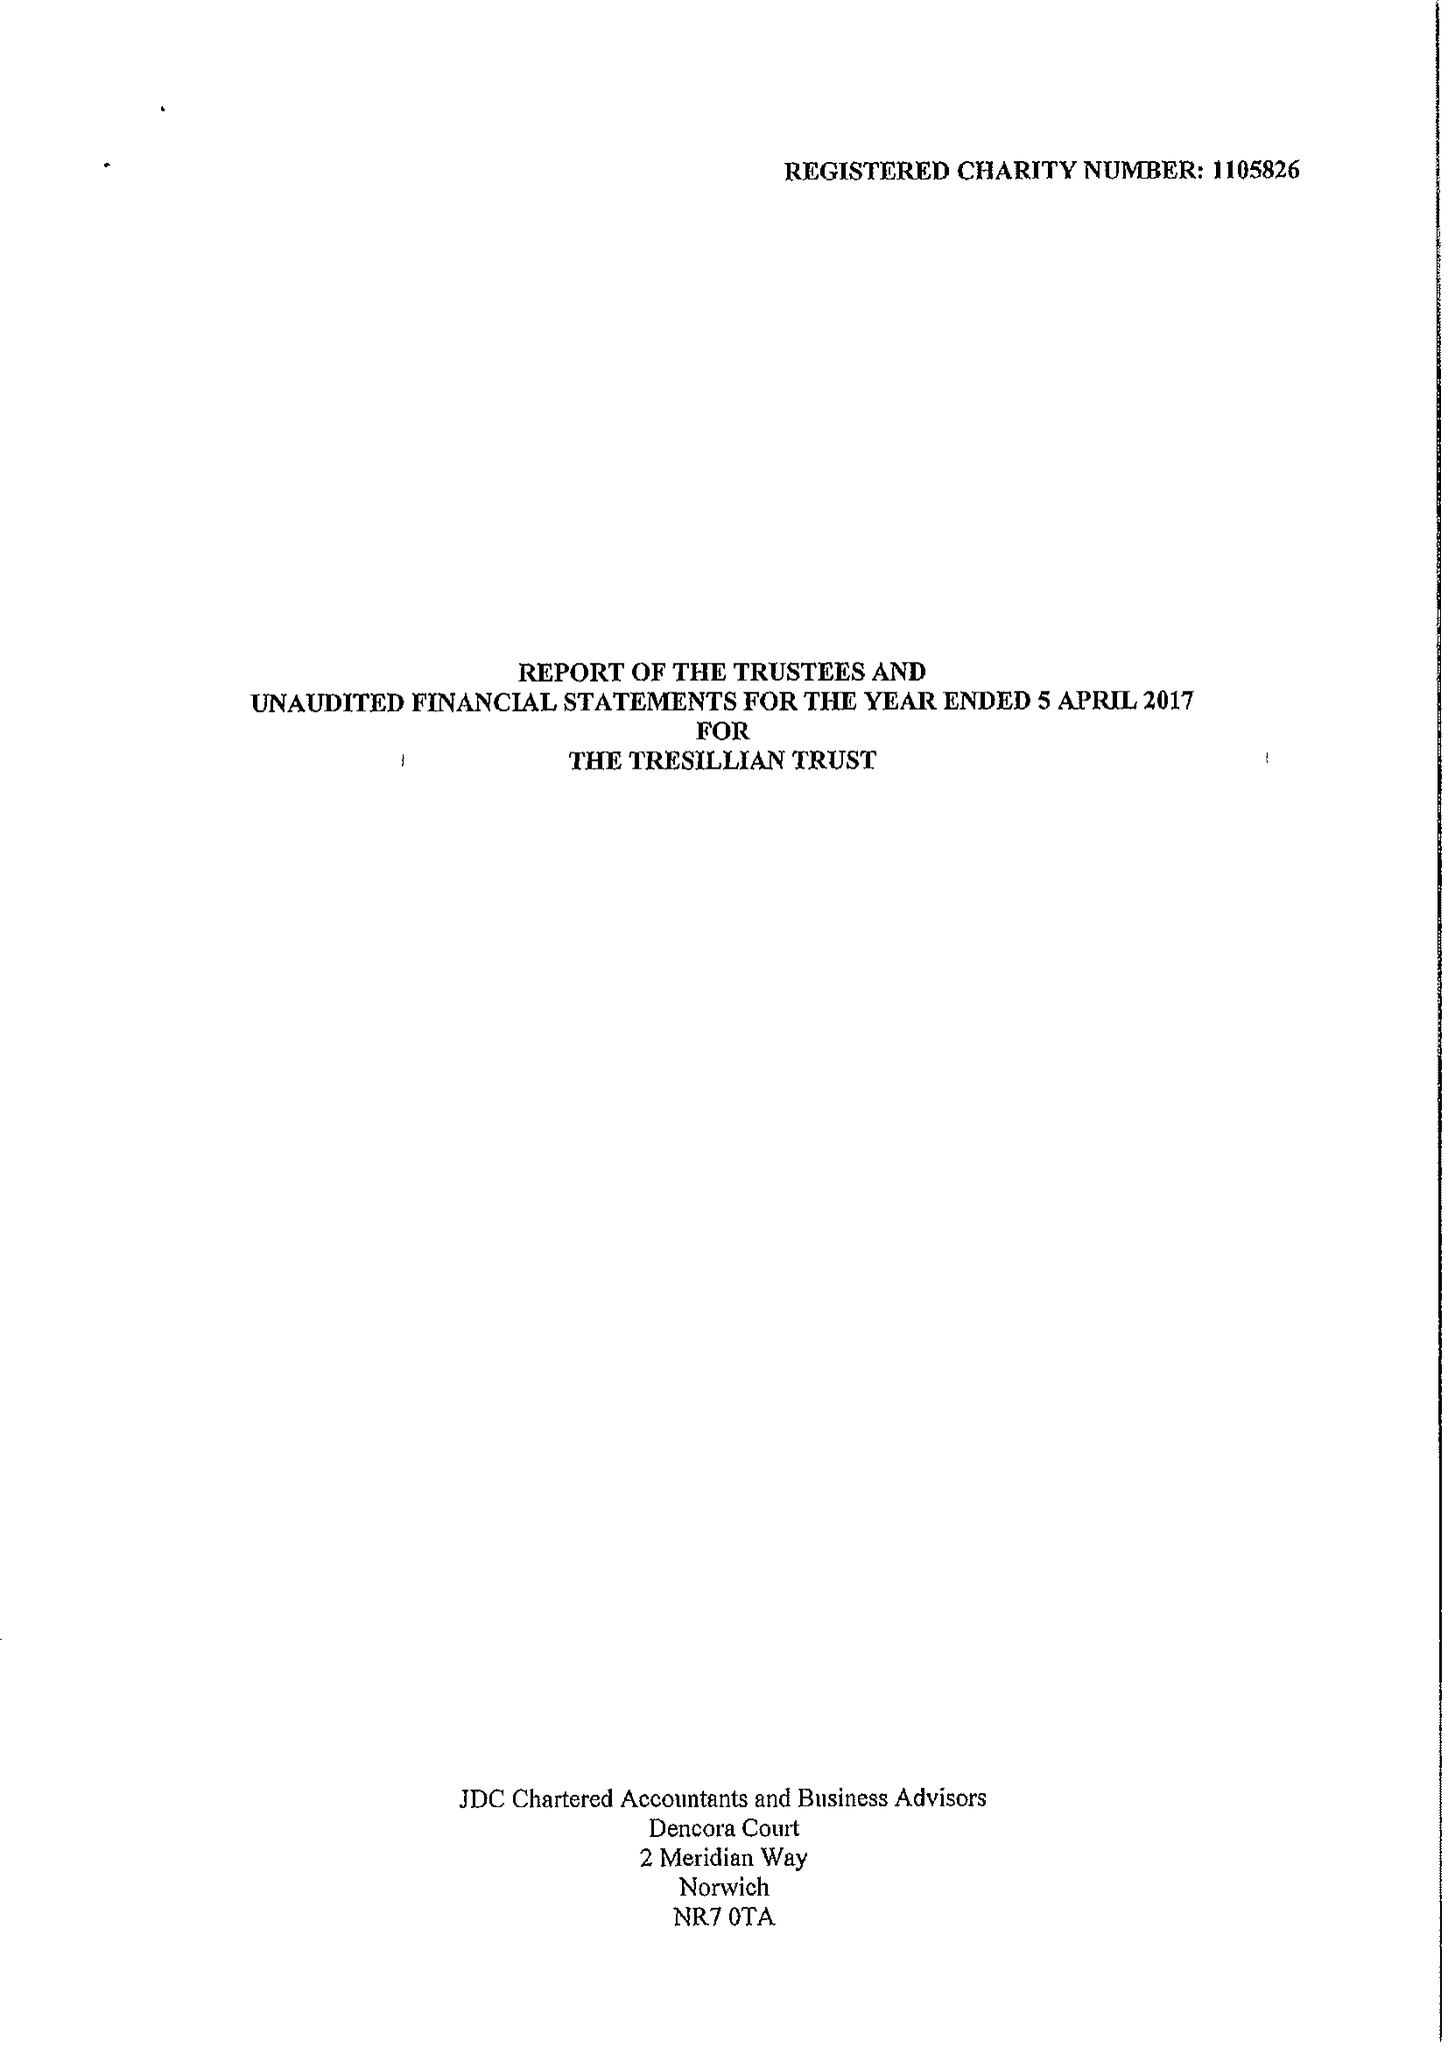What is the value for the charity_number?
Answer the question using a single word or phrase. 1105826 